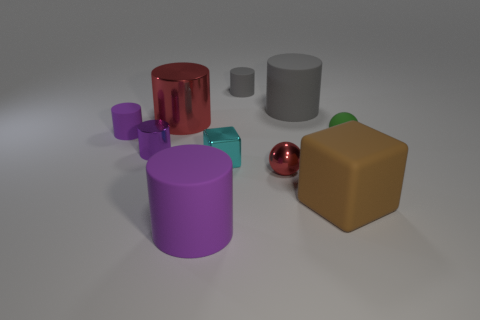Subtract all red metal cylinders. How many cylinders are left? 5 Subtract all spheres. How many objects are left? 8 Subtract 1 spheres. How many spheres are left? 1 Subtract all cyan blocks. How many blocks are left? 1 Subtract all green cylinders. Subtract all red cubes. How many cylinders are left? 6 Subtract all blue balls. How many yellow blocks are left? 0 Subtract all red shiny cubes. Subtract all brown rubber objects. How many objects are left? 9 Add 8 big gray cylinders. How many big gray cylinders are left? 9 Add 1 large cyan metallic things. How many large cyan metallic things exist? 1 Subtract 1 red cylinders. How many objects are left? 9 